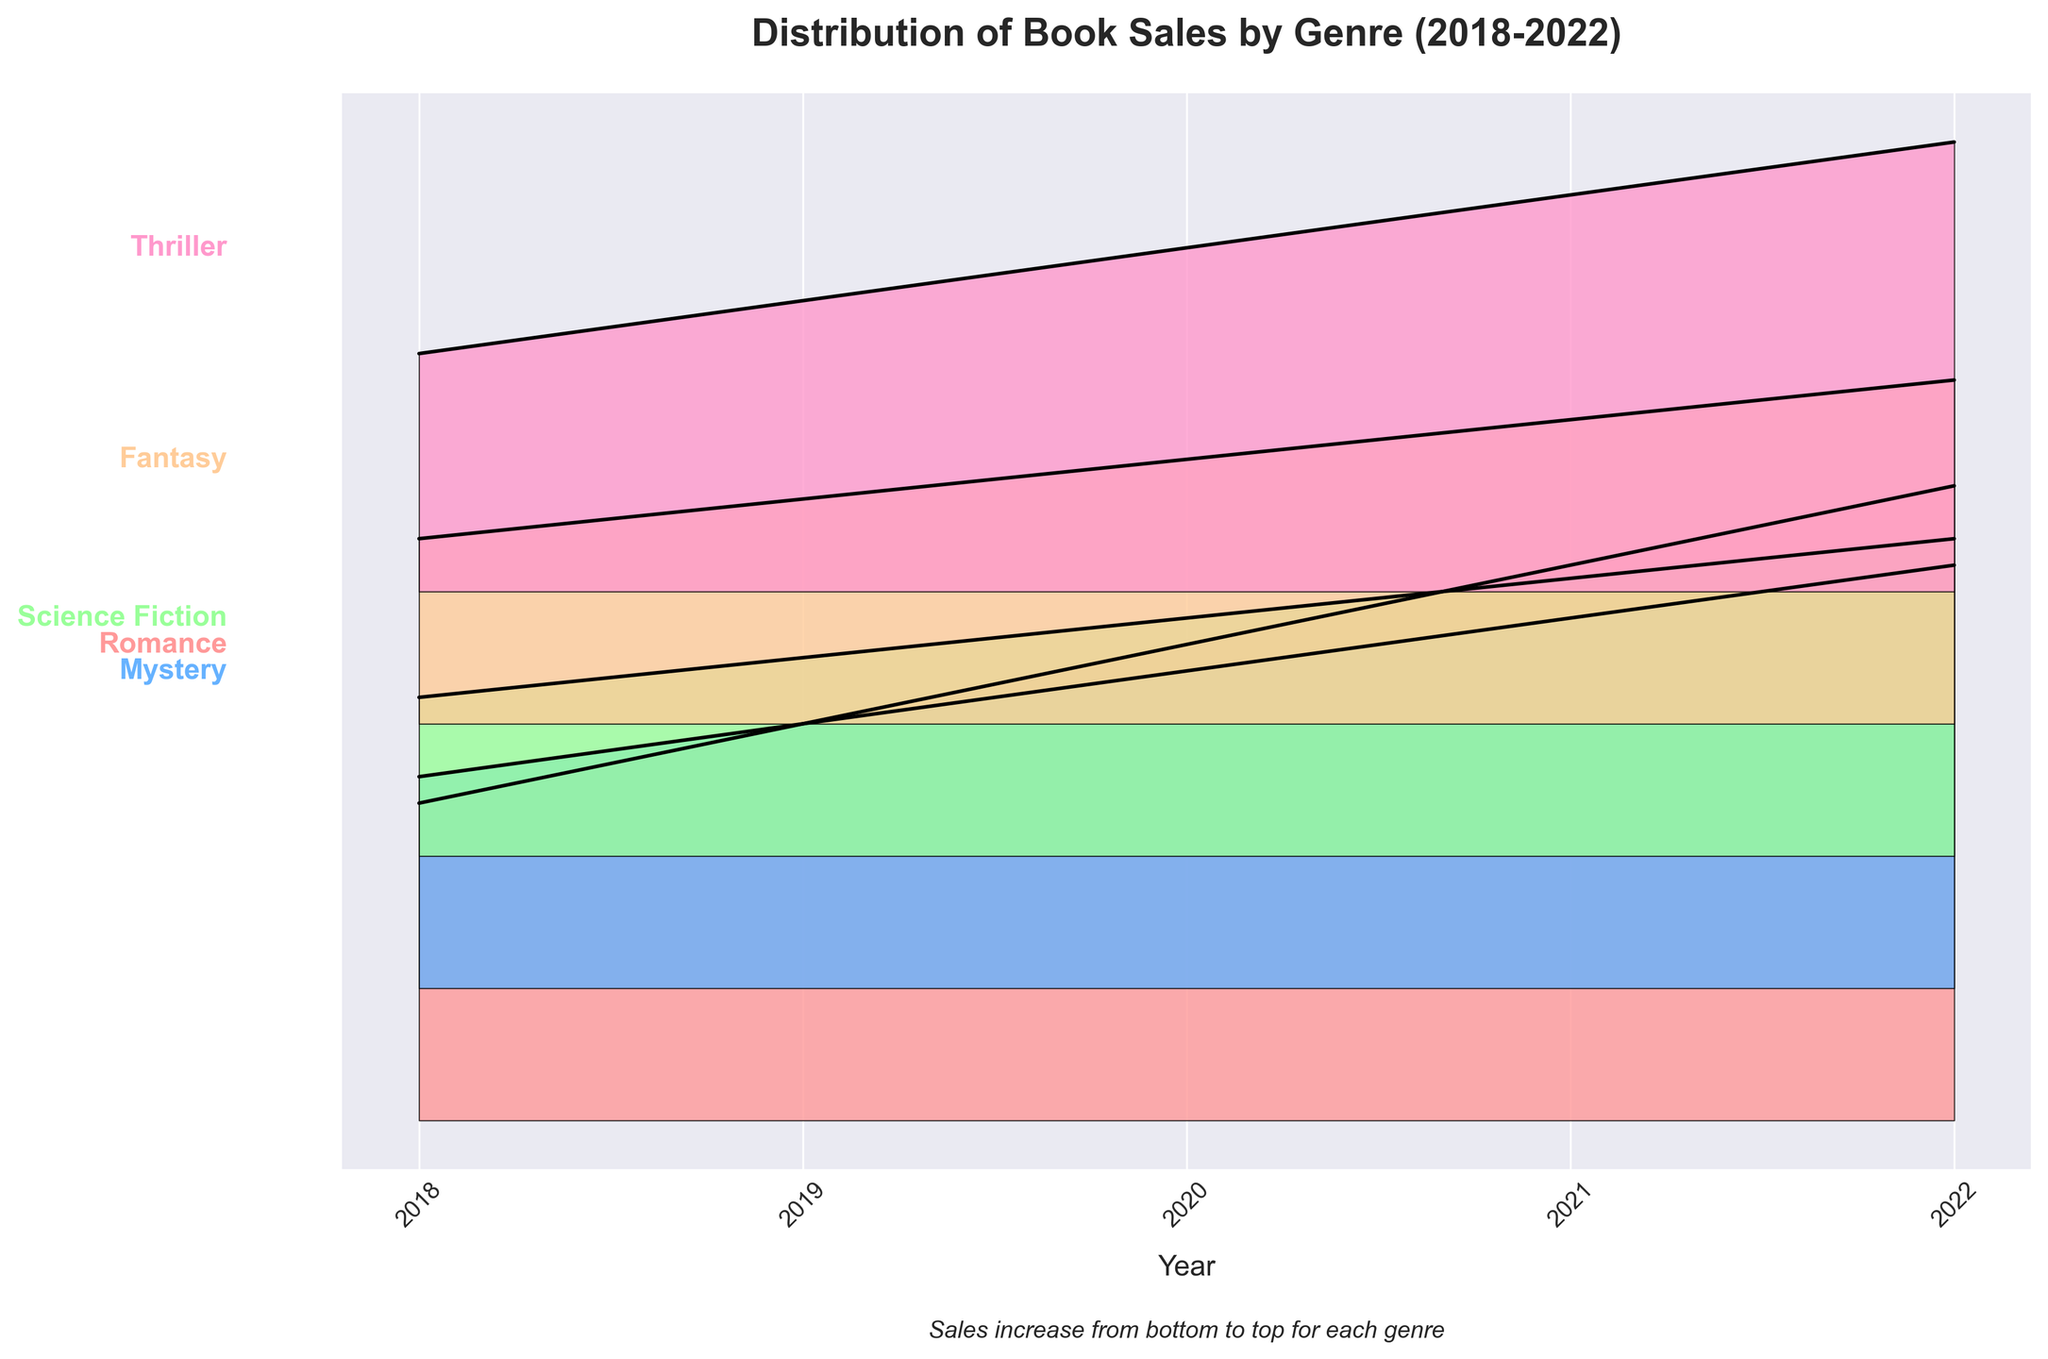Which genre had the highest book sales in 2022? Based on the ridgeline plot, the genre at the top in 2022 with the highest sales value is visible. The farthest peak belongs to Romance, indicating it had the highest book sales.
Answer: Romance What is the trend of book sales for the Mystery genre from 2018 to 2022? Observing the plot for the Mystery genre from 2018 to 2022, the sales values increase each year, indicating a steady upward trend in book sales.
Answer: Increasing Which genres show a consistent increase in book sales over the 5-year period? By examining the slope and continuity of the lines within the filled areas, it is clear that Romance, Mystery, Science Fiction, Fantasy, and Thriller all show consistent increases each year without any dips.
Answer: Romance, Mystery, Science Fiction, Fantasy, Thriller Compare the increase in book sales from 2018 to 2022 between the Romance and Thriller genres. Which genre experienced a greater increase? Romance starts at 1200 and ends at 2400 (an increase of 1200), while Thriller starts at 900 and ends at 1700 (an increase of 800). Comparing these figures, Romance experienced the greater increase in sales.
Answer: Romance What is the average book sales value for the Fantasy genre over the 5 years? The sales values for Fantasy are 700, 850, 1000, 1150, and 1300. Averaging these: (700 + 850 + 1000 + 1150 + 1300) / 5 = 1000.
Answer: 1000 Which genre had the least book sales in 2018? By looking at the genres at the bottom for the year 2018, Science Fiction is the lowest on the ridgeline plot for that year, indicating the least sales.
Answer: Science Fiction Did any genre experience a decline in sales in any of the years? Observing the plot lines for each genre and each year, none of the genres show a downward slope in any of the examined years, indicating no declines in sales.
Answer: No How much did Science Fiction book sales increase by from 2018 to 2019? Sales for Science Fiction increased from 600 in 2018 to 750 in 2019. The difference is 750 - 600 = 150.
Answer: 150 Which genre’s sales pattern shows the smallest year-to-year variation? By looking at the smoothness and consistency of the sales lines for each genre over the years, Mystery shows the smallest variation, as its line is the smoothest and most uniform.
Answer: Mystery If you visualize the ridgeline plot without overlapping, who had the highest end point above the baseline in 2022? The end point that's farthest above the baseline in 2022 indicates the highest value. It belongs to Romance genre for its highest final sales of 2400.
Answer: Romance 